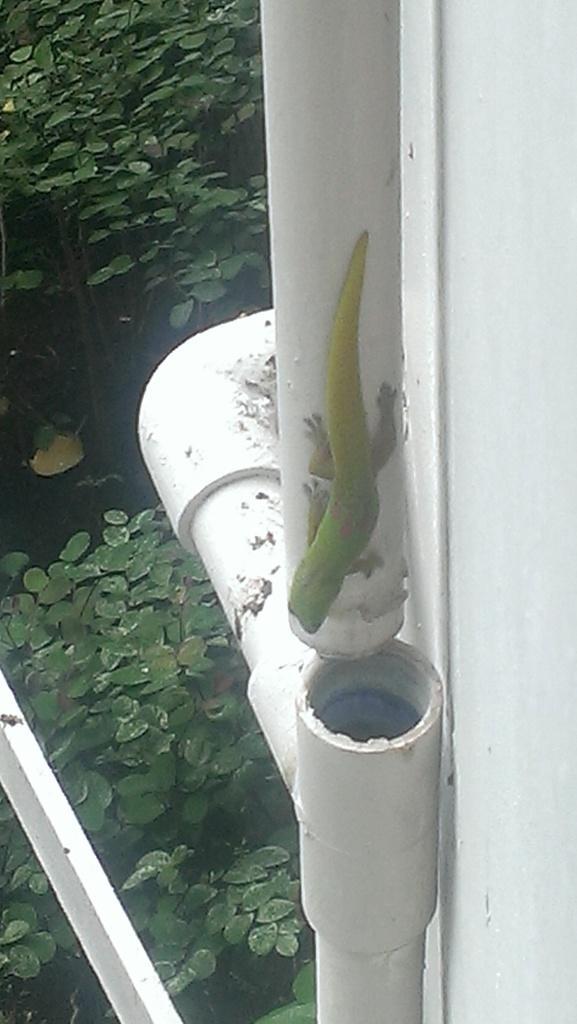In one or two sentences, can you explain what this image depicts? In this picture we can see a wall and pipes on the right side, in the background there are plants and leaves. 